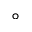<formula> <loc_0><loc_0><loc_500><loc_500>^ { \circ }</formula> 